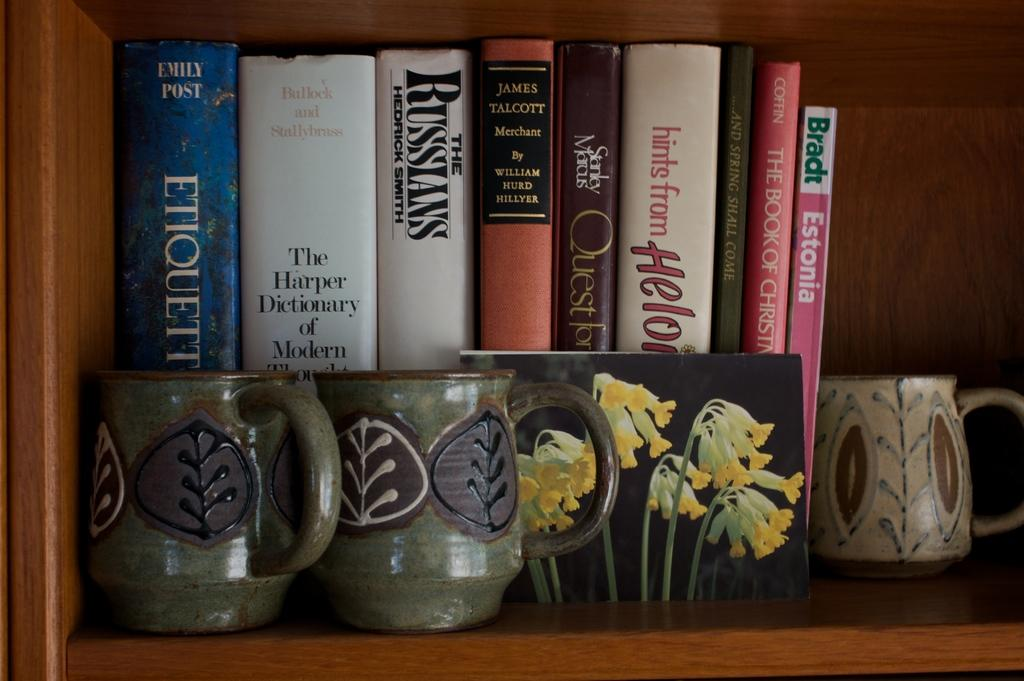<image>
Relay a brief, clear account of the picture shown. a book that is titled 'the russians' on the side of it 